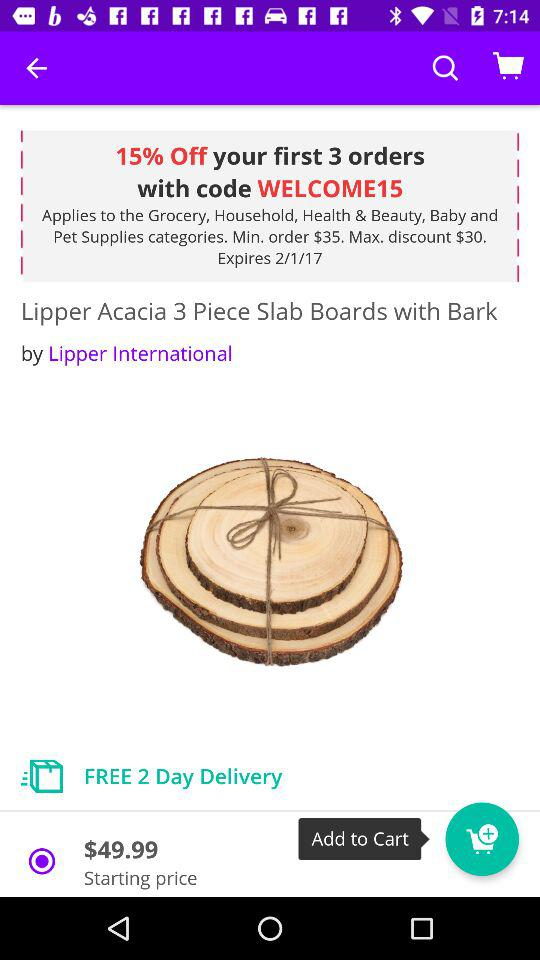How much percent is off on the first 3 orders? There is 15% off on the first three orders. 